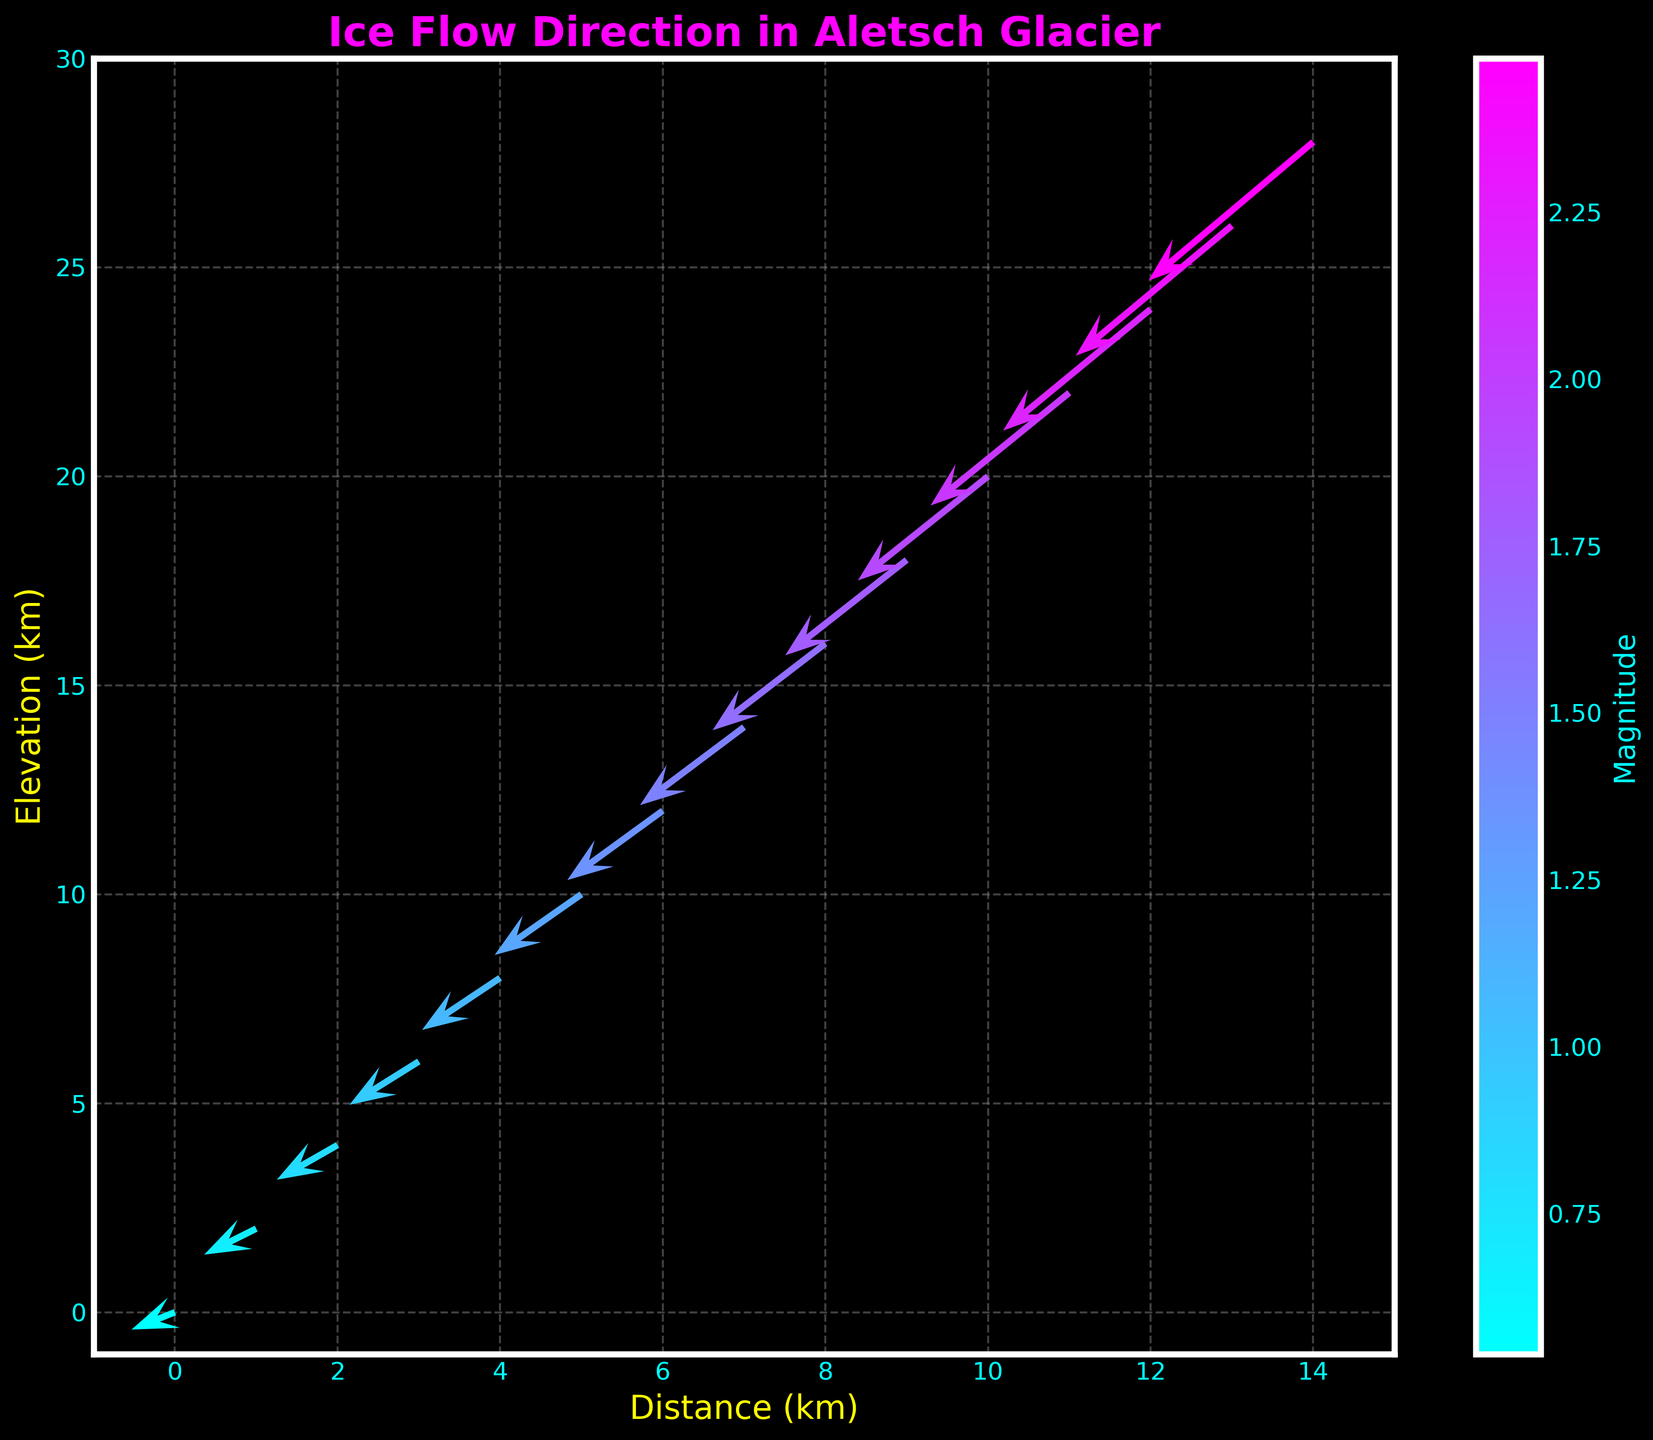What is the title of the plot? The title of the plot is written at the top. It is "Ice Flow Direction in Aletsch Glacier".
Answer: Ice Flow Direction in Aletsch Glacier How many data points are plotted in the figure? The number of data points can be counted by looking at the arrowheads; each arrow corresponds to a data point. There are 15 arrows.
Answer: 15 What does the color of the arrows represent in the plot? The color of the arrows represents the magnitude of the flow direction. This can be deduced from the color bar on the right side of the plot, which is labeled "Magnitude".
Answer: Magnitude Which arrow indicates the highest magnitude of ice flow, and what is its value? The highest magnitude is represented by the darkest color on the color scale. The darkest arrow corresponds to the last point (14, 28), with a magnitude value of 2.48.
Answer: 2.48 What are the labels of the x-axis and y-axis? The labels can be found next to the respective axes. The x-axis label is "Distance (km)" and the y-axis label is "Elevation (km)".
Answer: Distance (km) and Elevation (km) At which coordinate does the arrow representing the magnitude of 1.36 start? Locate the color corresponding to the magnitude value 1.36 on the color bar, then identify the arrow with that color. The arrow starts at the coordinate (6, 12).
Answer: (6, 12) What is the direction and magnitude of ice flow at the starting coordinates (1, 2)? Look at the arrow originating from (1, 2). It points leftwards and slightly downwards with a medium shade color. The arrow's components are u = -0.6 and v = -0.3 with a magnitude of 0.67.
Answer: Left-down, 0.67 How does the magnitude of ice flow change as we move from top to bottom in the direction of distance? Magnitude increases steadily as we move from the point with coordinates (0, 0) to (14, 28), indicated by increasingly darker colored arrows and the corresponding magnitude values.
Answer: It increases Which arrow has the smallest magnitude, and where is it located? Locate the lightest colored arrow, which represents the smallest magnitude. The smallest magnitude value is 0.54, found at the location (0, 0).
Answer: (0, 0) How does the flow direction of ice change from the first to the last arrow in the plot? The direction of flow indicated by the arrows changes gradually from mostly leftwards to slightly left-downwards as we move down the plot.
Answer: Mostly left to left-downwards 